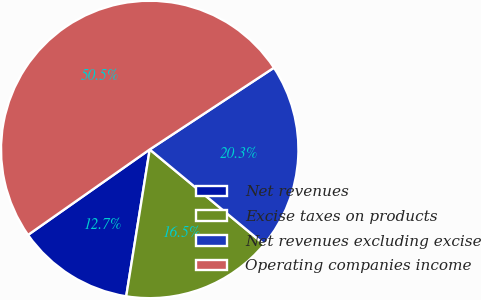Convert chart to OTSL. <chart><loc_0><loc_0><loc_500><loc_500><pie_chart><fcel>Net revenues<fcel>Excise taxes on products<fcel>Net revenues excluding excise<fcel>Operating companies income<nl><fcel>12.73%<fcel>16.51%<fcel>20.28%<fcel>50.48%<nl></chart> 